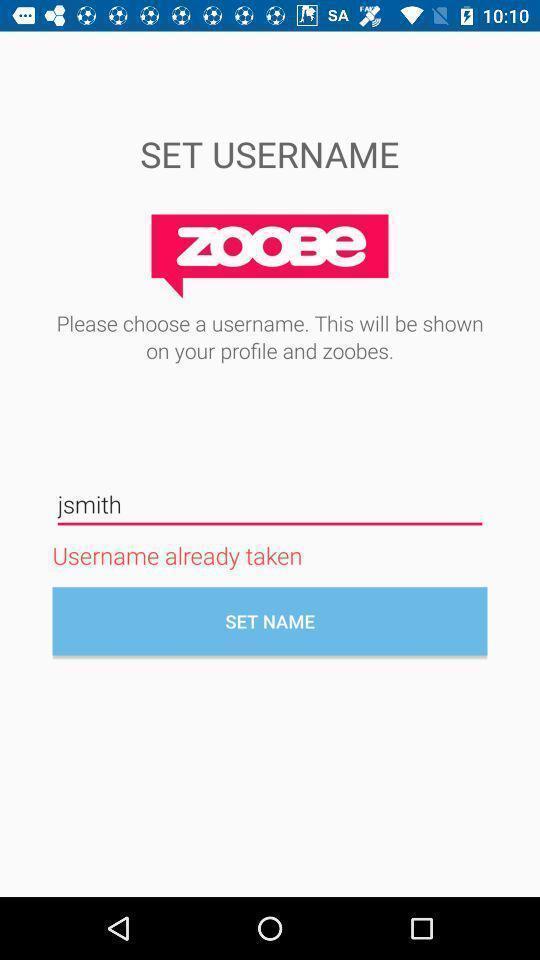Describe the key features of this screenshot. Page displaying to set username. 